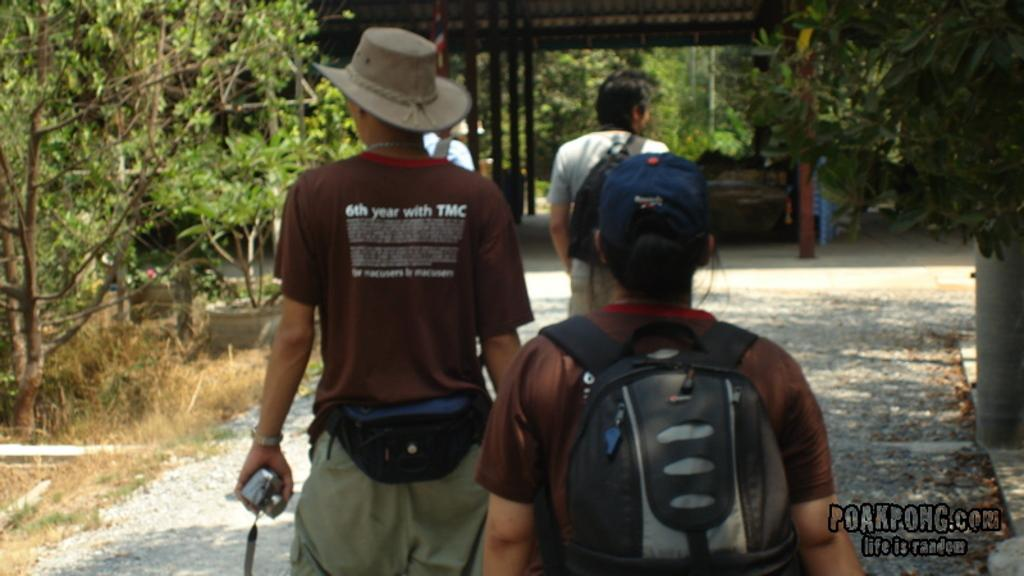<image>
Relay a brief, clear account of the picture shown. A few people walking down a path, one of which has 6th year with TMC written on the back of his shirt. 